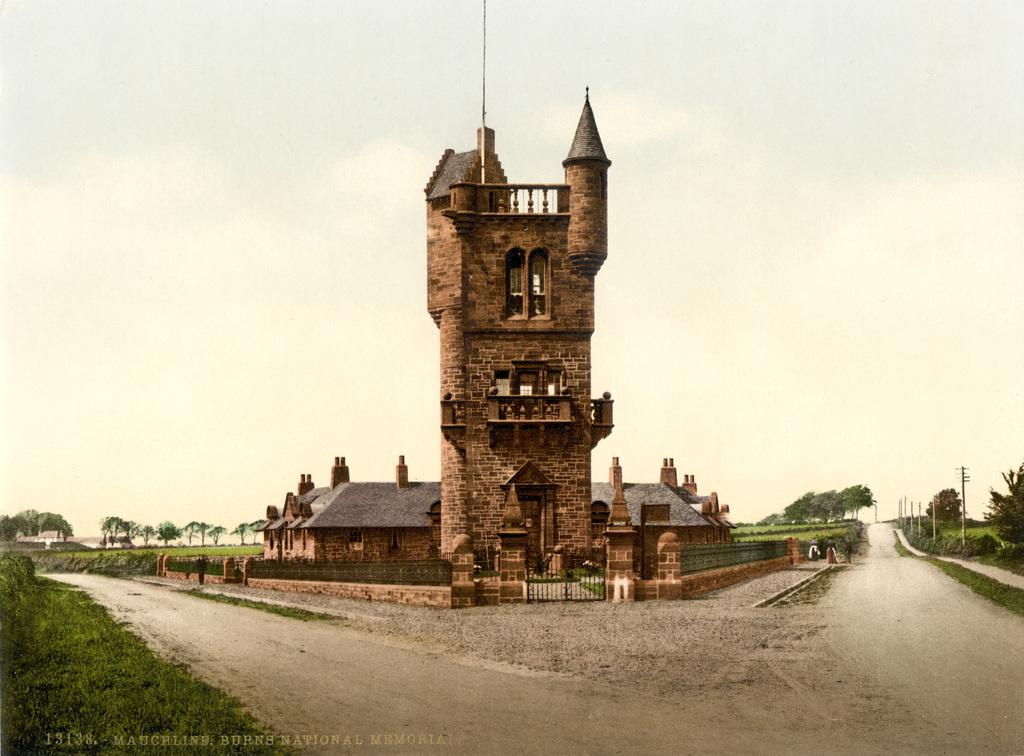What type of structures can be seen in the image? There are buildings in the image. What is the purpose of the gate in the image? The gate in the image is likely used for access control or to demarcate a boundary. What type of information is displayed in the image? Current polls are present in the image. What type of vegetation can be seen in the image? There are plants and trees in the image. What is visible at the top of the image? The sky is visible at the top of the image. What type of company is depicted on the farm in the image? There is no company or farm present in the image. What is the hope for the future of the trees in the image? There is no indication of the future of the trees in the image, as it only shows their current state. 